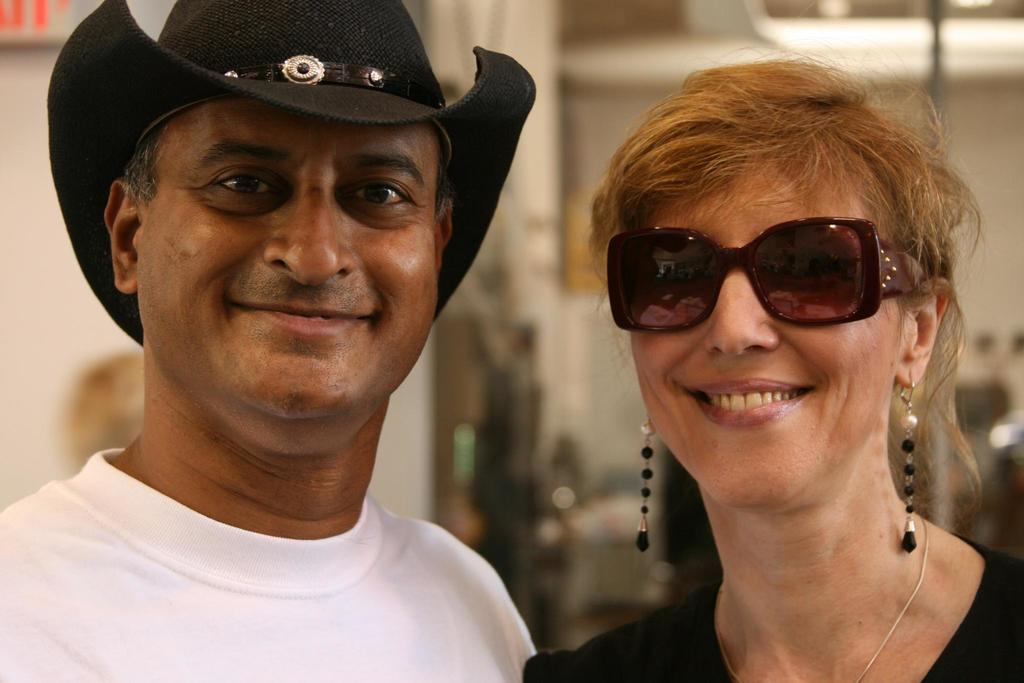What is the gender of the person in the image wearing a hat? The person wearing a hat in the image is a man. What accessory is the man wearing in the image? The man is wearing a hat. What is the gender of the person in the image wearing glasses? The person wearing glasses in the image is a woman. What is the woman wearing on her face in the image? The woman is wearing glasses. What expression does the woman have in the image? The woman is smiling in the image. How would you describe the background of the image? The background of the image is blurred. What can be seen in the image that provides illumination? There are lights visible in the image. What type of bird can be seen sitting on the tub in the image? There is no bird or tub present in the image. 